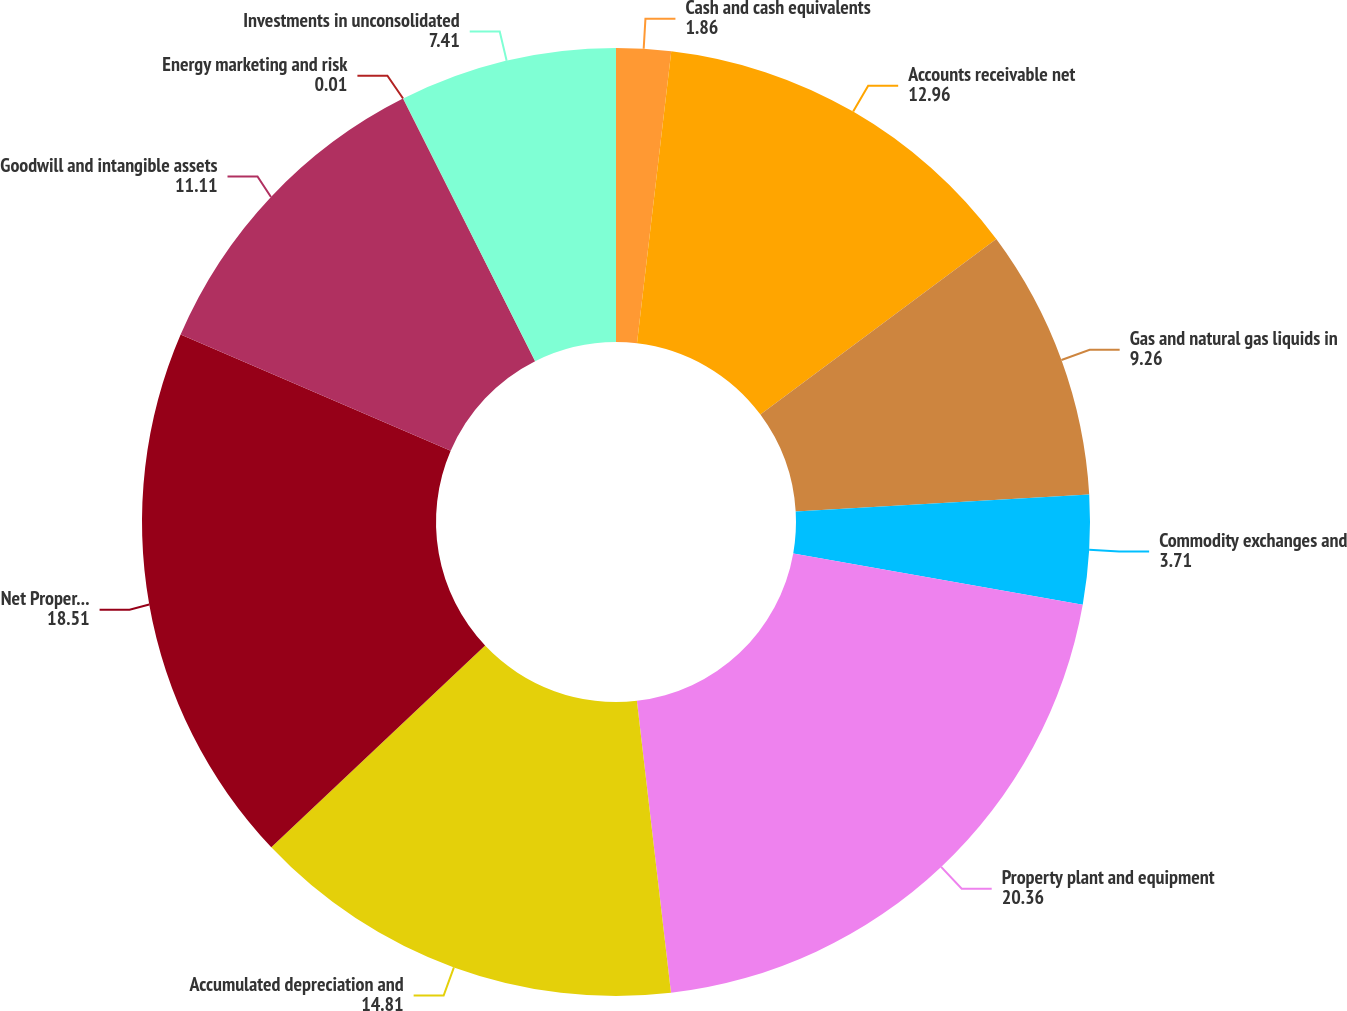<chart> <loc_0><loc_0><loc_500><loc_500><pie_chart><fcel>Cash and cash equivalents<fcel>Accounts receivable net<fcel>Gas and natural gas liquids in<fcel>Commodity exchanges and<fcel>Property plant and equipment<fcel>Accumulated depreciation and<fcel>Net Property Plant and<fcel>Goodwill and intangible assets<fcel>Energy marketing and risk<fcel>Investments in unconsolidated<nl><fcel>1.86%<fcel>12.96%<fcel>9.26%<fcel>3.71%<fcel>20.36%<fcel>14.81%<fcel>18.51%<fcel>11.11%<fcel>0.01%<fcel>7.41%<nl></chart> 